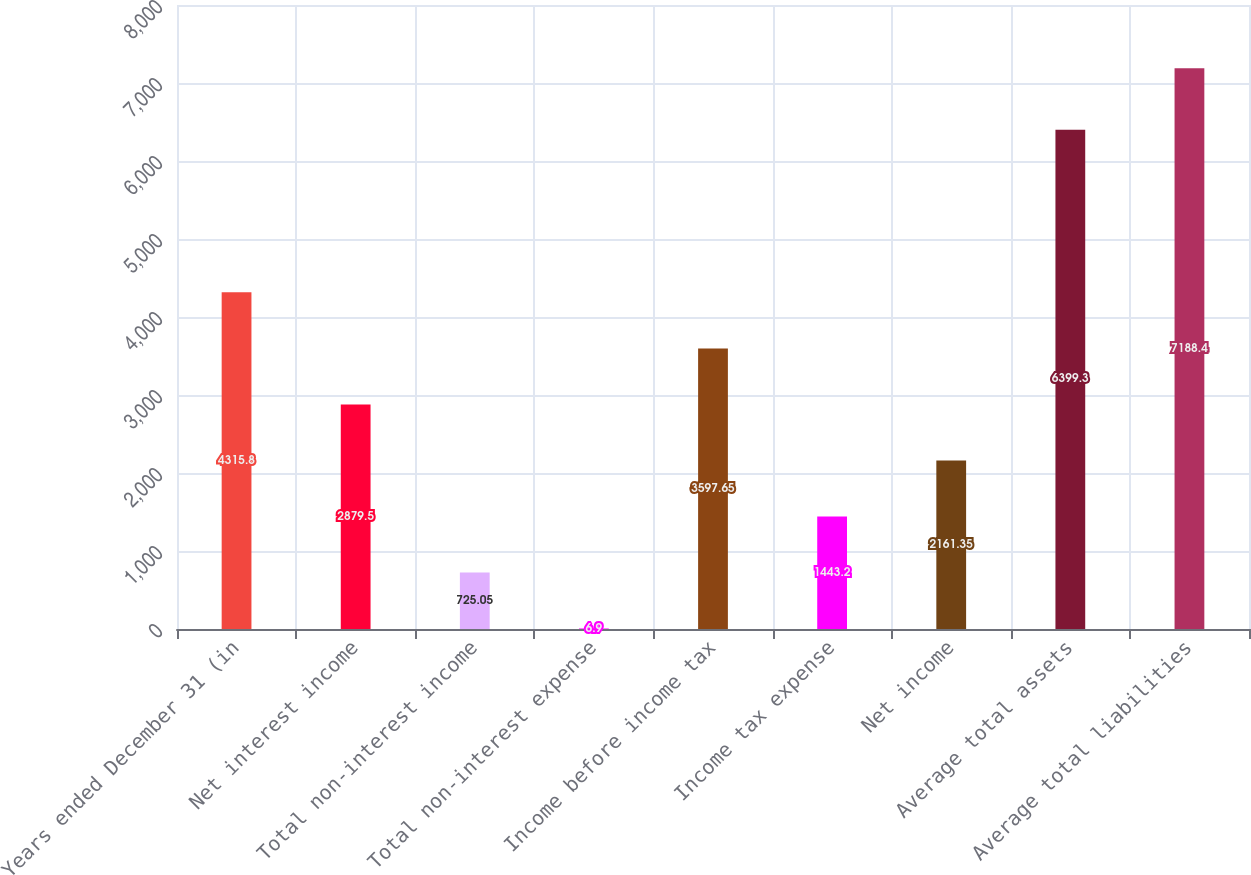Convert chart. <chart><loc_0><loc_0><loc_500><loc_500><bar_chart><fcel>Years ended December 31 (in<fcel>Net interest income<fcel>Total non-interest income<fcel>Total non-interest expense<fcel>Income before income tax<fcel>Income tax expense<fcel>Net income<fcel>Average total assets<fcel>Average total liabilities<nl><fcel>4315.8<fcel>2879.5<fcel>725.05<fcel>6.9<fcel>3597.65<fcel>1443.2<fcel>2161.35<fcel>6399.3<fcel>7188.4<nl></chart> 